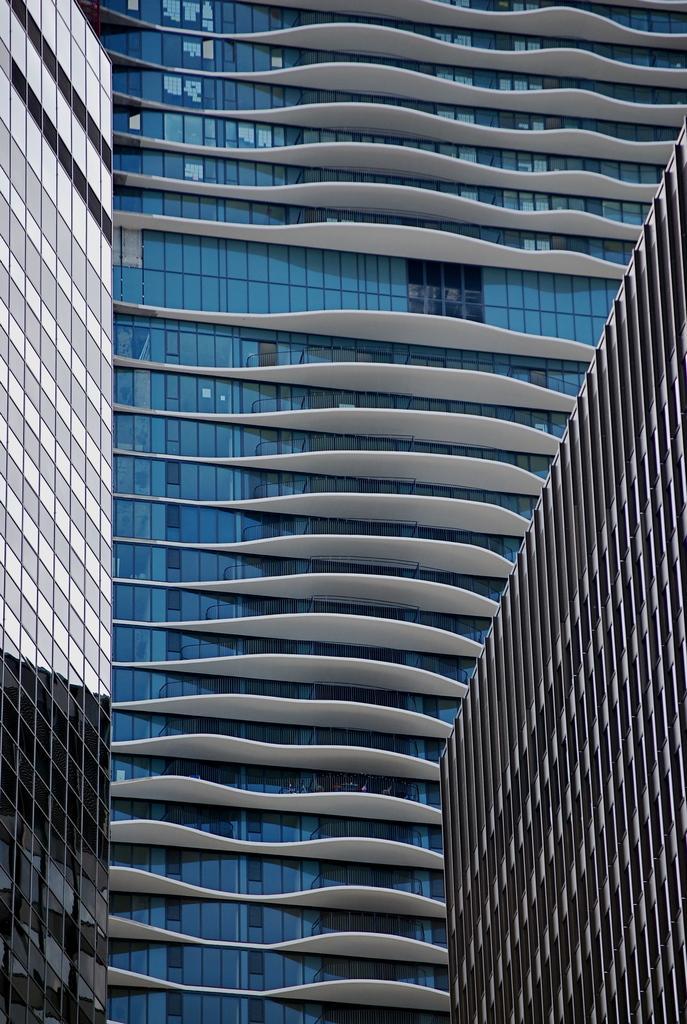How would you summarize this image in a sentence or two? In the image we can see three buildings. 